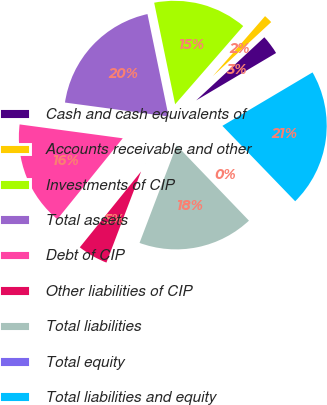Convert chart. <chart><loc_0><loc_0><loc_500><loc_500><pie_chart><fcel>Cash and cash equivalents of<fcel>Accounts receivable and other<fcel>Investments of CIP<fcel>Total assets<fcel>Debt of CIP<fcel>Other liabilities of CIP<fcel>Total liabilities<fcel>Total equity<fcel>Total liabilities and equity<nl><fcel>3.37%<fcel>1.71%<fcel>14.64%<fcel>19.63%<fcel>16.31%<fcel>5.03%<fcel>17.97%<fcel>0.04%<fcel>21.3%<nl></chart> 